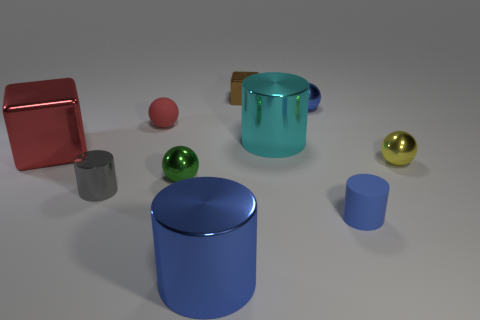Is the material of the small cylinder on the left side of the tiny green object the same as the cylinder that is behind the green object?
Offer a terse response. Yes. There is a blue object in front of the small rubber object right of the small brown cube; what shape is it?
Offer a very short reply. Cylinder. Is there anything else that is the same color as the tiny block?
Provide a succinct answer. No. Are there any big things that are to the right of the tiny shiny object behind the small metal sphere behind the big shiny cube?
Offer a very short reply. Yes. There is a metal cube that is in front of the small red matte sphere; is its color the same as the matte object that is on the left side of the big blue metal cylinder?
Provide a short and direct response. Yes. What material is the brown object that is the same size as the green shiny sphere?
Your response must be concise. Metal. There is a cube that is left of the block that is to the right of the blue shiny thing in front of the red metal thing; what is its size?
Provide a short and direct response. Large. What number of other objects are the same material as the small block?
Your response must be concise. 7. What size is the cylinder that is behind the yellow thing?
Make the answer very short. Large. How many tiny metallic things are both to the right of the gray metallic cylinder and in front of the brown cube?
Your answer should be compact. 3. 